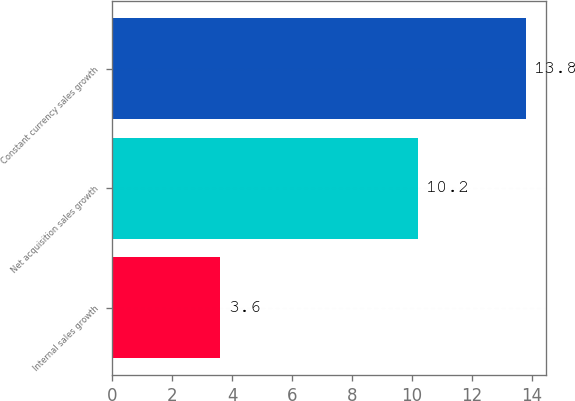<chart> <loc_0><loc_0><loc_500><loc_500><bar_chart><fcel>Internal sales growth<fcel>Net acquisition sales growth<fcel>Constant currency sales growth<nl><fcel>3.6<fcel>10.2<fcel>13.8<nl></chart> 